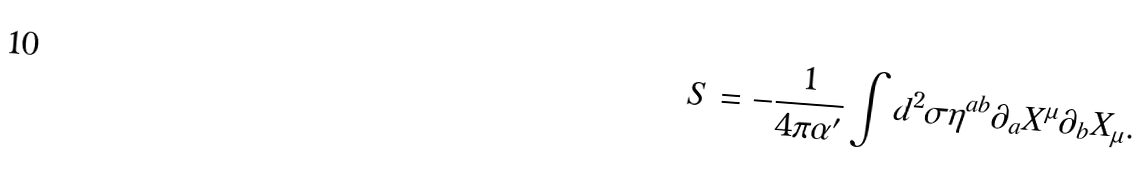Convert formula to latex. <formula><loc_0><loc_0><loc_500><loc_500>S = - \frac { 1 } { 4 \pi \alpha ^ { \prime } } \int d ^ { 2 } \sigma \eta ^ { a b } \partial _ { a } X ^ { \mu } \partial _ { b } X _ { \mu } .</formula> 